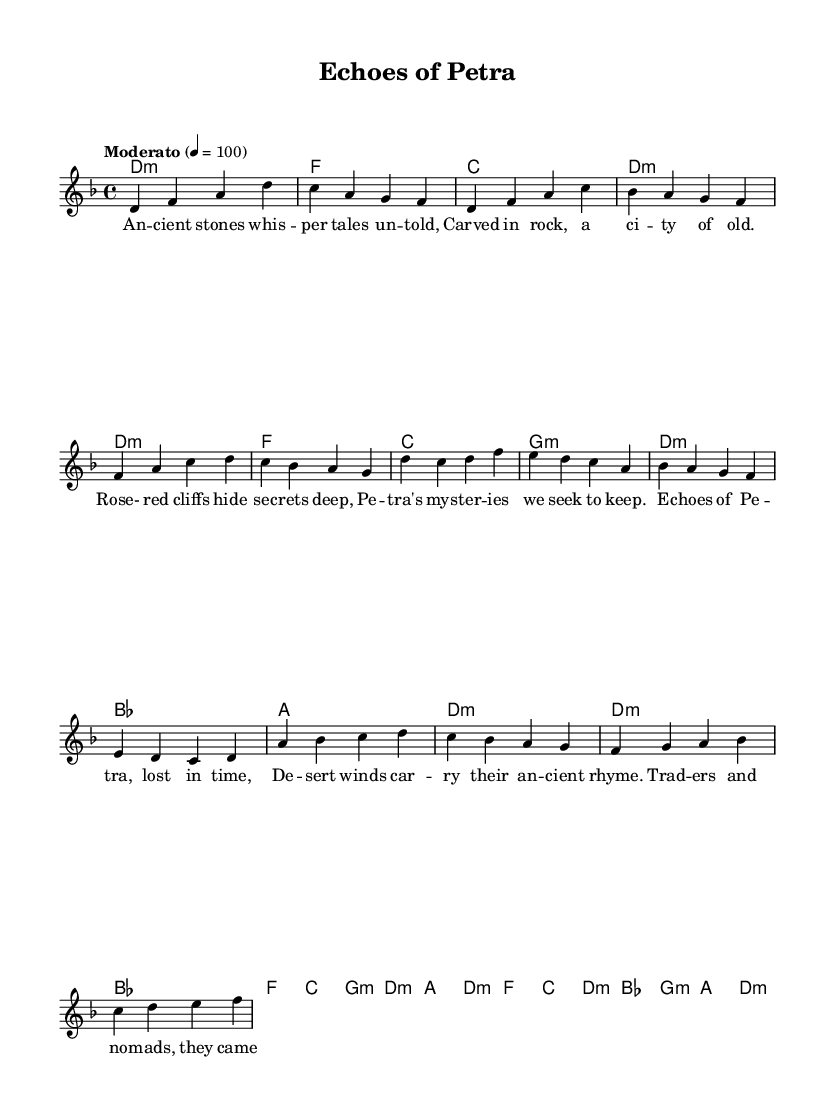What is the key signature of this music? The key signature is indicated at the beginning of the score, showing two flats which corresponds to D minor.
Answer: D minor What is the time signature of the piece? The time signature is found at the beginning of the score after the key signature and is indicated as 4/4, meaning there are four beats per measure.
Answer: 4/4 What is the tempo marking for this piece? The tempo marking is stated at the beginning, showing "Moderato" with a metronome marking of 100, which indicates a moderate speed.
Answer: Moderato 100 How many measures are in the chorus section? By counting the measures specifically labeled as the chorus from the score, we find there are four measures in this section.
Answer: 4 What is the harmony used in the bridge? The harmonies for the bridge section consist of F major, C major, D minor, and B flat major, which are all indicated in the chord mode for that part.
Answer: F, C, D minor, B flat What is the theme of the lyrics in the first verse? The lyrics describe ancient stones and the secrets of Petra, referencing history and ancient narratives embedded in the landscape, focusing on its mysterious qualities.
Answer: Ancient stones whisper tales untold What type of song is this classified as? The song falls under the category of folk music as it reflects themes of ancient cities and lost civilizations, with storytelling elements typical of folk traditions.
Answer: Folk music 